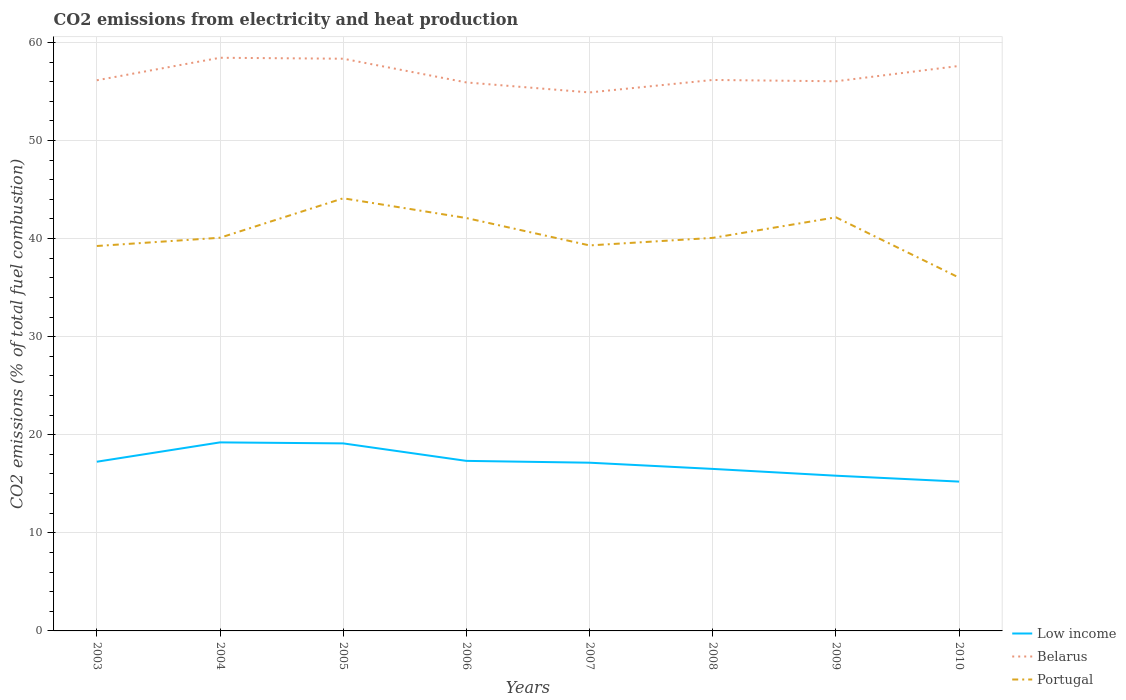Across all years, what is the maximum amount of CO2 emitted in Belarus?
Your answer should be compact. 54.9. In which year was the amount of CO2 emitted in Low income maximum?
Provide a succinct answer. 2010. What is the total amount of CO2 emitted in Low income in the graph?
Your response must be concise. 2.7. What is the difference between the highest and the second highest amount of CO2 emitted in Portugal?
Provide a succinct answer. 8.09. How many lines are there?
Your answer should be compact. 3. How many years are there in the graph?
Keep it short and to the point. 8. Does the graph contain any zero values?
Your answer should be very brief. No. Where does the legend appear in the graph?
Your response must be concise. Bottom right. What is the title of the graph?
Your answer should be very brief. CO2 emissions from electricity and heat production. Does "Pakistan" appear as one of the legend labels in the graph?
Provide a succinct answer. No. What is the label or title of the Y-axis?
Keep it short and to the point. CO2 emissions (% of total fuel combustion). What is the CO2 emissions (% of total fuel combustion) in Low income in 2003?
Give a very brief answer. 17.25. What is the CO2 emissions (% of total fuel combustion) in Belarus in 2003?
Keep it short and to the point. 56.14. What is the CO2 emissions (% of total fuel combustion) in Portugal in 2003?
Give a very brief answer. 39.24. What is the CO2 emissions (% of total fuel combustion) in Low income in 2004?
Keep it short and to the point. 19.22. What is the CO2 emissions (% of total fuel combustion) of Belarus in 2004?
Provide a succinct answer. 58.43. What is the CO2 emissions (% of total fuel combustion) of Portugal in 2004?
Your response must be concise. 40.08. What is the CO2 emissions (% of total fuel combustion) in Low income in 2005?
Offer a terse response. 19.12. What is the CO2 emissions (% of total fuel combustion) in Belarus in 2005?
Your response must be concise. 58.34. What is the CO2 emissions (% of total fuel combustion) in Portugal in 2005?
Your answer should be very brief. 44.11. What is the CO2 emissions (% of total fuel combustion) in Low income in 2006?
Provide a short and direct response. 17.34. What is the CO2 emissions (% of total fuel combustion) of Belarus in 2006?
Your answer should be very brief. 55.92. What is the CO2 emissions (% of total fuel combustion) in Portugal in 2006?
Offer a very short reply. 42.09. What is the CO2 emissions (% of total fuel combustion) in Low income in 2007?
Ensure brevity in your answer.  17.15. What is the CO2 emissions (% of total fuel combustion) of Belarus in 2007?
Ensure brevity in your answer.  54.9. What is the CO2 emissions (% of total fuel combustion) in Portugal in 2007?
Offer a terse response. 39.3. What is the CO2 emissions (% of total fuel combustion) in Low income in 2008?
Provide a short and direct response. 16.52. What is the CO2 emissions (% of total fuel combustion) of Belarus in 2008?
Offer a terse response. 56.17. What is the CO2 emissions (% of total fuel combustion) in Portugal in 2008?
Offer a terse response. 40.07. What is the CO2 emissions (% of total fuel combustion) of Low income in 2009?
Give a very brief answer. 15.82. What is the CO2 emissions (% of total fuel combustion) of Belarus in 2009?
Ensure brevity in your answer.  56.04. What is the CO2 emissions (% of total fuel combustion) in Portugal in 2009?
Ensure brevity in your answer.  42.17. What is the CO2 emissions (% of total fuel combustion) in Low income in 2010?
Offer a very short reply. 15.22. What is the CO2 emissions (% of total fuel combustion) of Belarus in 2010?
Make the answer very short. 57.6. What is the CO2 emissions (% of total fuel combustion) of Portugal in 2010?
Your answer should be compact. 36.02. Across all years, what is the maximum CO2 emissions (% of total fuel combustion) of Low income?
Give a very brief answer. 19.22. Across all years, what is the maximum CO2 emissions (% of total fuel combustion) in Belarus?
Your answer should be compact. 58.43. Across all years, what is the maximum CO2 emissions (% of total fuel combustion) in Portugal?
Make the answer very short. 44.11. Across all years, what is the minimum CO2 emissions (% of total fuel combustion) of Low income?
Keep it short and to the point. 15.22. Across all years, what is the minimum CO2 emissions (% of total fuel combustion) in Belarus?
Keep it short and to the point. 54.9. Across all years, what is the minimum CO2 emissions (% of total fuel combustion) of Portugal?
Provide a short and direct response. 36.02. What is the total CO2 emissions (% of total fuel combustion) in Low income in the graph?
Your response must be concise. 137.64. What is the total CO2 emissions (% of total fuel combustion) in Belarus in the graph?
Ensure brevity in your answer.  453.53. What is the total CO2 emissions (% of total fuel combustion) of Portugal in the graph?
Keep it short and to the point. 323.08. What is the difference between the CO2 emissions (% of total fuel combustion) in Low income in 2003 and that in 2004?
Make the answer very short. -1.97. What is the difference between the CO2 emissions (% of total fuel combustion) of Belarus in 2003 and that in 2004?
Provide a short and direct response. -2.29. What is the difference between the CO2 emissions (% of total fuel combustion) of Portugal in 2003 and that in 2004?
Your answer should be very brief. -0.84. What is the difference between the CO2 emissions (% of total fuel combustion) in Low income in 2003 and that in 2005?
Your answer should be very brief. -1.87. What is the difference between the CO2 emissions (% of total fuel combustion) in Belarus in 2003 and that in 2005?
Provide a succinct answer. -2.2. What is the difference between the CO2 emissions (% of total fuel combustion) of Portugal in 2003 and that in 2005?
Ensure brevity in your answer.  -4.86. What is the difference between the CO2 emissions (% of total fuel combustion) of Low income in 2003 and that in 2006?
Make the answer very short. -0.09. What is the difference between the CO2 emissions (% of total fuel combustion) in Belarus in 2003 and that in 2006?
Make the answer very short. 0.22. What is the difference between the CO2 emissions (% of total fuel combustion) of Portugal in 2003 and that in 2006?
Make the answer very short. -2.85. What is the difference between the CO2 emissions (% of total fuel combustion) in Low income in 2003 and that in 2007?
Keep it short and to the point. 0.1. What is the difference between the CO2 emissions (% of total fuel combustion) in Belarus in 2003 and that in 2007?
Provide a short and direct response. 1.24. What is the difference between the CO2 emissions (% of total fuel combustion) of Portugal in 2003 and that in 2007?
Your response must be concise. -0.06. What is the difference between the CO2 emissions (% of total fuel combustion) in Low income in 2003 and that in 2008?
Keep it short and to the point. 0.73. What is the difference between the CO2 emissions (% of total fuel combustion) in Belarus in 2003 and that in 2008?
Provide a short and direct response. -0.03. What is the difference between the CO2 emissions (% of total fuel combustion) in Portugal in 2003 and that in 2008?
Keep it short and to the point. -0.83. What is the difference between the CO2 emissions (% of total fuel combustion) of Low income in 2003 and that in 2009?
Your answer should be very brief. 1.43. What is the difference between the CO2 emissions (% of total fuel combustion) in Belarus in 2003 and that in 2009?
Your answer should be very brief. 0.1. What is the difference between the CO2 emissions (% of total fuel combustion) in Portugal in 2003 and that in 2009?
Your answer should be very brief. -2.92. What is the difference between the CO2 emissions (% of total fuel combustion) of Low income in 2003 and that in 2010?
Ensure brevity in your answer.  2.03. What is the difference between the CO2 emissions (% of total fuel combustion) in Belarus in 2003 and that in 2010?
Make the answer very short. -1.46. What is the difference between the CO2 emissions (% of total fuel combustion) in Portugal in 2003 and that in 2010?
Offer a very short reply. 3.23. What is the difference between the CO2 emissions (% of total fuel combustion) in Low income in 2004 and that in 2005?
Ensure brevity in your answer.  0.1. What is the difference between the CO2 emissions (% of total fuel combustion) of Belarus in 2004 and that in 2005?
Provide a succinct answer. 0.1. What is the difference between the CO2 emissions (% of total fuel combustion) in Portugal in 2004 and that in 2005?
Your response must be concise. -4.02. What is the difference between the CO2 emissions (% of total fuel combustion) of Low income in 2004 and that in 2006?
Your answer should be compact. 1.89. What is the difference between the CO2 emissions (% of total fuel combustion) of Belarus in 2004 and that in 2006?
Ensure brevity in your answer.  2.52. What is the difference between the CO2 emissions (% of total fuel combustion) of Portugal in 2004 and that in 2006?
Provide a succinct answer. -2.01. What is the difference between the CO2 emissions (% of total fuel combustion) in Low income in 2004 and that in 2007?
Ensure brevity in your answer.  2.07. What is the difference between the CO2 emissions (% of total fuel combustion) of Belarus in 2004 and that in 2007?
Ensure brevity in your answer.  3.54. What is the difference between the CO2 emissions (% of total fuel combustion) in Portugal in 2004 and that in 2007?
Make the answer very short. 0.78. What is the difference between the CO2 emissions (% of total fuel combustion) in Low income in 2004 and that in 2008?
Offer a very short reply. 2.7. What is the difference between the CO2 emissions (% of total fuel combustion) in Belarus in 2004 and that in 2008?
Your response must be concise. 2.26. What is the difference between the CO2 emissions (% of total fuel combustion) of Portugal in 2004 and that in 2008?
Provide a succinct answer. 0.01. What is the difference between the CO2 emissions (% of total fuel combustion) in Low income in 2004 and that in 2009?
Give a very brief answer. 3.4. What is the difference between the CO2 emissions (% of total fuel combustion) of Belarus in 2004 and that in 2009?
Your answer should be very brief. 2.4. What is the difference between the CO2 emissions (% of total fuel combustion) of Portugal in 2004 and that in 2009?
Offer a very short reply. -2.08. What is the difference between the CO2 emissions (% of total fuel combustion) of Low income in 2004 and that in 2010?
Offer a terse response. 4. What is the difference between the CO2 emissions (% of total fuel combustion) of Belarus in 2004 and that in 2010?
Give a very brief answer. 0.83. What is the difference between the CO2 emissions (% of total fuel combustion) of Portugal in 2004 and that in 2010?
Provide a short and direct response. 4.07. What is the difference between the CO2 emissions (% of total fuel combustion) of Low income in 2005 and that in 2006?
Make the answer very short. 1.78. What is the difference between the CO2 emissions (% of total fuel combustion) of Belarus in 2005 and that in 2006?
Your answer should be compact. 2.42. What is the difference between the CO2 emissions (% of total fuel combustion) of Portugal in 2005 and that in 2006?
Keep it short and to the point. 2.01. What is the difference between the CO2 emissions (% of total fuel combustion) of Low income in 2005 and that in 2007?
Your answer should be very brief. 1.97. What is the difference between the CO2 emissions (% of total fuel combustion) in Belarus in 2005 and that in 2007?
Provide a short and direct response. 3.44. What is the difference between the CO2 emissions (% of total fuel combustion) of Portugal in 2005 and that in 2007?
Your answer should be compact. 4.8. What is the difference between the CO2 emissions (% of total fuel combustion) in Low income in 2005 and that in 2008?
Ensure brevity in your answer.  2.6. What is the difference between the CO2 emissions (% of total fuel combustion) of Belarus in 2005 and that in 2008?
Make the answer very short. 2.17. What is the difference between the CO2 emissions (% of total fuel combustion) of Portugal in 2005 and that in 2008?
Provide a short and direct response. 4.04. What is the difference between the CO2 emissions (% of total fuel combustion) of Low income in 2005 and that in 2009?
Your answer should be compact. 3.29. What is the difference between the CO2 emissions (% of total fuel combustion) of Belarus in 2005 and that in 2009?
Offer a very short reply. 2.3. What is the difference between the CO2 emissions (% of total fuel combustion) in Portugal in 2005 and that in 2009?
Keep it short and to the point. 1.94. What is the difference between the CO2 emissions (% of total fuel combustion) in Low income in 2005 and that in 2010?
Your response must be concise. 3.89. What is the difference between the CO2 emissions (% of total fuel combustion) of Belarus in 2005 and that in 2010?
Keep it short and to the point. 0.74. What is the difference between the CO2 emissions (% of total fuel combustion) of Portugal in 2005 and that in 2010?
Your response must be concise. 8.09. What is the difference between the CO2 emissions (% of total fuel combustion) of Low income in 2006 and that in 2007?
Keep it short and to the point. 0.19. What is the difference between the CO2 emissions (% of total fuel combustion) in Belarus in 2006 and that in 2007?
Ensure brevity in your answer.  1.02. What is the difference between the CO2 emissions (% of total fuel combustion) in Portugal in 2006 and that in 2007?
Provide a succinct answer. 2.79. What is the difference between the CO2 emissions (% of total fuel combustion) in Low income in 2006 and that in 2008?
Keep it short and to the point. 0.82. What is the difference between the CO2 emissions (% of total fuel combustion) in Belarus in 2006 and that in 2008?
Make the answer very short. -0.25. What is the difference between the CO2 emissions (% of total fuel combustion) in Portugal in 2006 and that in 2008?
Your response must be concise. 2.02. What is the difference between the CO2 emissions (% of total fuel combustion) in Low income in 2006 and that in 2009?
Offer a very short reply. 1.51. What is the difference between the CO2 emissions (% of total fuel combustion) in Belarus in 2006 and that in 2009?
Your response must be concise. -0.12. What is the difference between the CO2 emissions (% of total fuel combustion) in Portugal in 2006 and that in 2009?
Offer a very short reply. -0.07. What is the difference between the CO2 emissions (% of total fuel combustion) of Low income in 2006 and that in 2010?
Provide a succinct answer. 2.11. What is the difference between the CO2 emissions (% of total fuel combustion) in Belarus in 2006 and that in 2010?
Provide a succinct answer. -1.68. What is the difference between the CO2 emissions (% of total fuel combustion) in Portugal in 2006 and that in 2010?
Your answer should be compact. 6.08. What is the difference between the CO2 emissions (% of total fuel combustion) of Low income in 2007 and that in 2008?
Provide a succinct answer. 0.63. What is the difference between the CO2 emissions (% of total fuel combustion) of Belarus in 2007 and that in 2008?
Your answer should be compact. -1.27. What is the difference between the CO2 emissions (% of total fuel combustion) in Portugal in 2007 and that in 2008?
Offer a very short reply. -0.77. What is the difference between the CO2 emissions (% of total fuel combustion) of Low income in 2007 and that in 2009?
Keep it short and to the point. 1.33. What is the difference between the CO2 emissions (% of total fuel combustion) of Belarus in 2007 and that in 2009?
Your response must be concise. -1.14. What is the difference between the CO2 emissions (% of total fuel combustion) in Portugal in 2007 and that in 2009?
Make the answer very short. -2.86. What is the difference between the CO2 emissions (% of total fuel combustion) of Low income in 2007 and that in 2010?
Provide a short and direct response. 1.93. What is the difference between the CO2 emissions (% of total fuel combustion) of Belarus in 2007 and that in 2010?
Offer a terse response. -2.7. What is the difference between the CO2 emissions (% of total fuel combustion) in Portugal in 2007 and that in 2010?
Your answer should be compact. 3.29. What is the difference between the CO2 emissions (% of total fuel combustion) of Low income in 2008 and that in 2009?
Your answer should be very brief. 0.69. What is the difference between the CO2 emissions (% of total fuel combustion) in Belarus in 2008 and that in 2009?
Offer a terse response. 0.13. What is the difference between the CO2 emissions (% of total fuel combustion) of Portugal in 2008 and that in 2009?
Ensure brevity in your answer.  -2.1. What is the difference between the CO2 emissions (% of total fuel combustion) in Low income in 2008 and that in 2010?
Give a very brief answer. 1.29. What is the difference between the CO2 emissions (% of total fuel combustion) of Belarus in 2008 and that in 2010?
Your answer should be very brief. -1.43. What is the difference between the CO2 emissions (% of total fuel combustion) in Portugal in 2008 and that in 2010?
Provide a short and direct response. 4.05. What is the difference between the CO2 emissions (% of total fuel combustion) of Low income in 2009 and that in 2010?
Offer a very short reply. 0.6. What is the difference between the CO2 emissions (% of total fuel combustion) in Belarus in 2009 and that in 2010?
Offer a very short reply. -1.56. What is the difference between the CO2 emissions (% of total fuel combustion) of Portugal in 2009 and that in 2010?
Give a very brief answer. 6.15. What is the difference between the CO2 emissions (% of total fuel combustion) in Low income in 2003 and the CO2 emissions (% of total fuel combustion) in Belarus in 2004?
Your response must be concise. -41.18. What is the difference between the CO2 emissions (% of total fuel combustion) in Low income in 2003 and the CO2 emissions (% of total fuel combustion) in Portugal in 2004?
Make the answer very short. -22.83. What is the difference between the CO2 emissions (% of total fuel combustion) in Belarus in 2003 and the CO2 emissions (% of total fuel combustion) in Portugal in 2004?
Offer a very short reply. 16.06. What is the difference between the CO2 emissions (% of total fuel combustion) in Low income in 2003 and the CO2 emissions (% of total fuel combustion) in Belarus in 2005?
Provide a succinct answer. -41.09. What is the difference between the CO2 emissions (% of total fuel combustion) of Low income in 2003 and the CO2 emissions (% of total fuel combustion) of Portugal in 2005?
Ensure brevity in your answer.  -26.86. What is the difference between the CO2 emissions (% of total fuel combustion) in Belarus in 2003 and the CO2 emissions (% of total fuel combustion) in Portugal in 2005?
Provide a succinct answer. 12.03. What is the difference between the CO2 emissions (% of total fuel combustion) in Low income in 2003 and the CO2 emissions (% of total fuel combustion) in Belarus in 2006?
Your answer should be compact. -38.67. What is the difference between the CO2 emissions (% of total fuel combustion) in Low income in 2003 and the CO2 emissions (% of total fuel combustion) in Portugal in 2006?
Offer a terse response. -24.84. What is the difference between the CO2 emissions (% of total fuel combustion) in Belarus in 2003 and the CO2 emissions (% of total fuel combustion) in Portugal in 2006?
Provide a short and direct response. 14.05. What is the difference between the CO2 emissions (% of total fuel combustion) of Low income in 2003 and the CO2 emissions (% of total fuel combustion) of Belarus in 2007?
Make the answer very short. -37.65. What is the difference between the CO2 emissions (% of total fuel combustion) in Low income in 2003 and the CO2 emissions (% of total fuel combustion) in Portugal in 2007?
Your response must be concise. -22.05. What is the difference between the CO2 emissions (% of total fuel combustion) of Belarus in 2003 and the CO2 emissions (% of total fuel combustion) of Portugal in 2007?
Your response must be concise. 16.84. What is the difference between the CO2 emissions (% of total fuel combustion) in Low income in 2003 and the CO2 emissions (% of total fuel combustion) in Belarus in 2008?
Your answer should be very brief. -38.92. What is the difference between the CO2 emissions (% of total fuel combustion) in Low income in 2003 and the CO2 emissions (% of total fuel combustion) in Portugal in 2008?
Your answer should be very brief. -22.82. What is the difference between the CO2 emissions (% of total fuel combustion) of Belarus in 2003 and the CO2 emissions (% of total fuel combustion) of Portugal in 2008?
Keep it short and to the point. 16.07. What is the difference between the CO2 emissions (% of total fuel combustion) of Low income in 2003 and the CO2 emissions (% of total fuel combustion) of Belarus in 2009?
Your answer should be very brief. -38.79. What is the difference between the CO2 emissions (% of total fuel combustion) of Low income in 2003 and the CO2 emissions (% of total fuel combustion) of Portugal in 2009?
Your answer should be compact. -24.92. What is the difference between the CO2 emissions (% of total fuel combustion) in Belarus in 2003 and the CO2 emissions (% of total fuel combustion) in Portugal in 2009?
Your response must be concise. 13.97. What is the difference between the CO2 emissions (% of total fuel combustion) of Low income in 2003 and the CO2 emissions (% of total fuel combustion) of Belarus in 2010?
Offer a very short reply. -40.35. What is the difference between the CO2 emissions (% of total fuel combustion) of Low income in 2003 and the CO2 emissions (% of total fuel combustion) of Portugal in 2010?
Provide a succinct answer. -18.77. What is the difference between the CO2 emissions (% of total fuel combustion) in Belarus in 2003 and the CO2 emissions (% of total fuel combustion) in Portugal in 2010?
Give a very brief answer. 20.12. What is the difference between the CO2 emissions (% of total fuel combustion) of Low income in 2004 and the CO2 emissions (% of total fuel combustion) of Belarus in 2005?
Provide a succinct answer. -39.11. What is the difference between the CO2 emissions (% of total fuel combustion) in Low income in 2004 and the CO2 emissions (% of total fuel combustion) in Portugal in 2005?
Your answer should be very brief. -24.89. What is the difference between the CO2 emissions (% of total fuel combustion) of Belarus in 2004 and the CO2 emissions (% of total fuel combustion) of Portugal in 2005?
Give a very brief answer. 14.33. What is the difference between the CO2 emissions (% of total fuel combustion) in Low income in 2004 and the CO2 emissions (% of total fuel combustion) in Belarus in 2006?
Your answer should be compact. -36.7. What is the difference between the CO2 emissions (% of total fuel combustion) of Low income in 2004 and the CO2 emissions (% of total fuel combustion) of Portugal in 2006?
Provide a short and direct response. -22.87. What is the difference between the CO2 emissions (% of total fuel combustion) of Belarus in 2004 and the CO2 emissions (% of total fuel combustion) of Portugal in 2006?
Your answer should be very brief. 16.34. What is the difference between the CO2 emissions (% of total fuel combustion) of Low income in 2004 and the CO2 emissions (% of total fuel combustion) of Belarus in 2007?
Your response must be concise. -35.68. What is the difference between the CO2 emissions (% of total fuel combustion) in Low income in 2004 and the CO2 emissions (% of total fuel combustion) in Portugal in 2007?
Give a very brief answer. -20.08. What is the difference between the CO2 emissions (% of total fuel combustion) in Belarus in 2004 and the CO2 emissions (% of total fuel combustion) in Portugal in 2007?
Your answer should be compact. 19.13. What is the difference between the CO2 emissions (% of total fuel combustion) in Low income in 2004 and the CO2 emissions (% of total fuel combustion) in Belarus in 2008?
Offer a very short reply. -36.95. What is the difference between the CO2 emissions (% of total fuel combustion) in Low income in 2004 and the CO2 emissions (% of total fuel combustion) in Portugal in 2008?
Your response must be concise. -20.85. What is the difference between the CO2 emissions (% of total fuel combustion) of Belarus in 2004 and the CO2 emissions (% of total fuel combustion) of Portugal in 2008?
Your answer should be very brief. 18.36. What is the difference between the CO2 emissions (% of total fuel combustion) in Low income in 2004 and the CO2 emissions (% of total fuel combustion) in Belarus in 2009?
Ensure brevity in your answer.  -36.82. What is the difference between the CO2 emissions (% of total fuel combustion) of Low income in 2004 and the CO2 emissions (% of total fuel combustion) of Portugal in 2009?
Keep it short and to the point. -22.95. What is the difference between the CO2 emissions (% of total fuel combustion) in Belarus in 2004 and the CO2 emissions (% of total fuel combustion) in Portugal in 2009?
Ensure brevity in your answer.  16.27. What is the difference between the CO2 emissions (% of total fuel combustion) of Low income in 2004 and the CO2 emissions (% of total fuel combustion) of Belarus in 2010?
Offer a terse response. -38.38. What is the difference between the CO2 emissions (% of total fuel combustion) of Low income in 2004 and the CO2 emissions (% of total fuel combustion) of Portugal in 2010?
Your answer should be very brief. -16.79. What is the difference between the CO2 emissions (% of total fuel combustion) in Belarus in 2004 and the CO2 emissions (% of total fuel combustion) in Portugal in 2010?
Your response must be concise. 22.42. What is the difference between the CO2 emissions (% of total fuel combustion) in Low income in 2005 and the CO2 emissions (% of total fuel combustion) in Belarus in 2006?
Make the answer very short. -36.8. What is the difference between the CO2 emissions (% of total fuel combustion) in Low income in 2005 and the CO2 emissions (% of total fuel combustion) in Portugal in 2006?
Provide a succinct answer. -22.98. What is the difference between the CO2 emissions (% of total fuel combustion) in Belarus in 2005 and the CO2 emissions (% of total fuel combustion) in Portugal in 2006?
Make the answer very short. 16.24. What is the difference between the CO2 emissions (% of total fuel combustion) in Low income in 2005 and the CO2 emissions (% of total fuel combustion) in Belarus in 2007?
Ensure brevity in your answer.  -35.78. What is the difference between the CO2 emissions (% of total fuel combustion) in Low income in 2005 and the CO2 emissions (% of total fuel combustion) in Portugal in 2007?
Offer a very short reply. -20.18. What is the difference between the CO2 emissions (% of total fuel combustion) in Belarus in 2005 and the CO2 emissions (% of total fuel combustion) in Portugal in 2007?
Keep it short and to the point. 19.03. What is the difference between the CO2 emissions (% of total fuel combustion) in Low income in 2005 and the CO2 emissions (% of total fuel combustion) in Belarus in 2008?
Keep it short and to the point. -37.05. What is the difference between the CO2 emissions (% of total fuel combustion) in Low income in 2005 and the CO2 emissions (% of total fuel combustion) in Portugal in 2008?
Keep it short and to the point. -20.95. What is the difference between the CO2 emissions (% of total fuel combustion) of Belarus in 2005 and the CO2 emissions (% of total fuel combustion) of Portugal in 2008?
Make the answer very short. 18.27. What is the difference between the CO2 emissions (% of total fuel combustion) in Low income in 2005 and the CO2 emissions (% of total fuel combustion) in Belarus in 2009?
Ensure brevity in your answer.  -36.92. What is the difference between the CO2 emissions (% of total fuel combustion) in Low income in 2005 and the CO2 emissions (% of total fuel combustion) in Portugal in 2009?
Keep it short and to the point. -23.05. What is the difference between the CO2 emissions (% of total fuel combustion) of Belarus in 2005 and the CO2 emissions (% of total fuel combustion) of Portugal in 2009?
Your answer should be compact. 16.17. What is the difference between the CO2 emissions (% of total fuel combustion) in Low income in 2005 and the CO2 emissions (% of total fuel combustion) in Belarus in 2010?
Provide a short and direct response. -38.48. What is the difference between the CO2 emissions (% of total fuel combustion) of Low income in 2005 and the CO2 emissions (% of total fuel combustion) of Portugal in 2010?
Your response must be concise. -16.9. What is the difference between the CO2 emissions (% of total fuel combustion) in Belarus in 2005 and the CO2 emissions (% of total fuel combustion) in Portugal in 2010?
Your response must be concise. 22.32. What is the difference between the CO2 emissions (% of total fuel combustion) in Low income in 2006 and the CO2 emissions (% of total fuel combustion) in Belarus in 2007?
Your answer should be very brief. -37.56. What is the difference between the CO2 emissions (% of total fuel combustion) of Low income in 2006 and the CO2 emissions (% of total fuel combustion) of Portugal in 2007?
Your answer should be compact. -21.97. What is the difference between the CO2 emissions (% of total fuel combustion) of Belarus in 2006 and the CO2 emissions (% of total fuel combustion) of Portugal in 2007?
Offer a terse response. 16.62. What is the difference between the CO2 emissions (% of total fuel combustion) of Low income in 2006 and the CO2 emissions (% of total fuel combustion) of Belarus in 2008?
Keep it short and to the point. -38.83. What is the difference between the CO2 emissions (% of total fuel combustion) in Low income in 2006 and the CO2 emissions (% of total fuel combustion) in Portugal in 2008?
Your response must be concise. -22.73. What is the difference between the CO2 emissions (% of total fuel combustion) in Belarus in 2006 and the CO2 emissions (% of total fuel combustion) in Portugal in 2008?
Make the answer very short. 15.85. What is the difference between the CO2 emissions (% of total fuel combustion) in Low income in 2006 and the CO2 emissions (% of total fuel combustion) in Belarus in 2009?
Provide a short and direct response. -38.7. What is the difference between the CO2 emissions (% of total fuel combustion) of Low income in 2006 and the CO2 emissions (% of total fuel combustion) of Portugal in 2009?
Keep it short and to the point. -24.83. What is the difference between the CO2 emissions (% of total fuel combustion) in Belarus in 2006 and the CO2 emissions (% of total fuel combustion) in Portugal in 2009?
Offer a terse response. 13.75. What is the difference between the CO2 emissions (% of total fuel combustion) of Low income in 2006 and the CO2 emissions (% of total fuel combustion) of Belarus in 2010?
Offer a terse response. -40.26. What is the difference between the CO2 emissions (% of total fuel combustion) of Low income in 2006 and the CO2 emissions (% of total fuel combustion) of Portugal in 2010?
Your answer should be very brief. -18.68. What is the difference between the CO2 emissions (% of total fuel combustion) in Belarus in 2006 and the CO2 emissions (% of total fuel combustion) in Portugal in 2010?
Your answer should be very brief. 19.9. What is the difference between the CO2 emissions (% of total fuel combustion) of Low income in 2007 and the CO2 emissions (% of total fuel combustion) of Belarus in 2008?
Offer a very short reply. -39.02. What is the difference between the CO2 emissions (% of total fuel combustion) of Low income in 2007 and the CO2 emissions (% of total fuel combustion) of Portugal in 2008?
Ensure brevity in your answer.  -22.92. What is the difference between the CO2 emissions (% of total fuel combustion) in Belarus in 2007 and the CO2 emissions (% of total fuel combustion) in Portugal in 2008?
Keep it short and to the point. 14.83. What is the difference between the CO2 emissions (% of total fuel combustion) of Low income in 2007 and the CO2 emissions (% of total fuel combustion) of Belarus in 2009?
Make the answer very short. -38.89. What is the difference between the CO2 emissions (% of total fuel combustion) in Low income in 2007 and the CO2 emissions (% of total fuel combustion) in Portugal in 2009?
Provide a short and direct response. -25.02. What is the difference between the CO2 emissions (% of total fuel combustion) of Belarus in 2007 and the CO2 emissions (% of total fuel combustion) of Portugal in 2009?
Your answer should be very brief. 12.73. What is the difference between the CO2 emissions (% of total fuel combustion) in Low income in 2007 and the CO2 emissions (% of total fuel combustion) in Belarus in 2010?
Ensure brevity in your answer.  -40.45. What is the difference between the CO2 emissions (% of total fuel combustion) in Low income in 2007 and the CO2 emissions (% of total fuel combustion) in Portugal in 2010?
Keep it short and to the point. -18.87. What is the difference between the CO2 emissions (% of total fuel combustion) in Belarus in 2007 and the CO2 emissions (% of total fuel combustion) in Portugal in 2010?
Offer a terse response. 18.88. What is the difference between the CO2 emissions (% of total fuel combustion) in Low income in 2008 and the CO2 emissions (% of total fuel combustion) in Belarus in 2009?
Your answer should be very brief. -39.52. What is the difference between the CO2 emissions (% of total fuel combustion) of Low income in 2008 and the CO2 emissions (% of total fuel combustion) of Portugal in 2009?
Offer a very short reply. -25.65. What is the difference between the CO2 emissions (% of total fuel combustion) of Belarus in 2008 and the CO2 emissions (% of total fuel combustion) of Portugal in 2009?
Offer a very short reply. 14. What is the difference between the CO2 emissions (% of total fuel combustion) in Low income in 2008 and the CO2 emissions (% of total fuel combustion) in Belarus in 2010?
Give a very brief answer. -41.08. What is the difference between the CO2 emissions (% of total fuel combustion) in Low income in 2008 and the CO2 emissions (% of total fuel combustion) in Portugal in 2010?
Offer a very short reply. -19.5. What is the difference between the CO2 emissions (% of total fuel combustion) in Belarus in 2008 and the CO2 emissions (% of total fuel combustion) in Portugal in 2010?
Keep it short and to the point. 20.15. What is the difference between the CO2 emissions (% of total fuel combustion) of Low income in 2009 and the CO2 emissions (% of total fuel combustion) of Belarus in 2010?
Give a very brief answer. -41.78. What is the difference between the CO2 emissions (% of total fuel combustion) in Low income in 2009 and the CO2 emissions (% of total fuel combustion) in Portugal in 2010?
Provide a short and direct response. -20.19. What is the difference between the CO2 emissions (% of total fuel combustion) in Belarus in 2009 and the CO2 emissions (% of total fuel combustion) in Portugal in 2010?
Give a very brief answer. 20.02. What is the average CO2 emissions (% of total fuel combustion) of Low income per year?
Give a very brief answer. 17.21. What is the average CO2 emissions (% of total fuel combustion) in Belarus per year?
Ensure brevity in your answer.  56.69. What is the average CO2 emissions (% of total fuel combustion) of Portugal per year?
Offer a terse response. 40.39. In the year 2003, what is the difference between the CO2 emissions (% of total fuel combustion) of Low income and CO2 emissions (% of total fuel combustion) of Belarus?
Ensure brevity in your answer.  -38.89. In the year 2003, what is the difference between the CO2 emissions (% of total fuel combustion) in Low income and CO2 emissions (% of total fuel combustion) in Portugal?
Offer a terse response. -21.99. In the year 2003, what is the difference between the CO2 emissions (% of total fuel combustion) of Belarus and CO2 emissions (% of total fuel combustion) of Portugal?
Offer a terse response. 16.9. In the year 2004, what is the difference between the CO2 emissions (% of total fuel combustion) of Low income and CO2 emissions (% of total fuel combustion) of Belarus?
Your response must be concise. -39.21. In the year 2004, what is the difference between the CO2 emissions (% of total fuel combustion) of Low income and CO2 emissions (% of total fuel combustion) of Portugal?
Your answer should be compact. -20.86. In the year 2004, what is the difference between the CO2 emissions (% of total fuel combustion) in Belarus and CO2 emissions (% of total fuel combustion) in Portugal?
Your answer should be compact. 18.35. In the year 2005, what is the difference between the CO2 emissions (% of total fuel combustion) in Low income and CO2 emissions (% of total fuel combustion) in Belarus?
Your answer should be compact. -39.22. In the year 2005, what is the difference between the CO2 emissions (% of total fuel combustion) in Low income and CO2 emissions (% of total fuel combustion) in Portugal?
Keep it short and to the point. -24.99. In the year 2005, what is the difference between the CO2 emissions (% of total fuel combustion) of Belarus and CO2 emissions (% of total fuel combustion) of Portugal?
Offer a very short reply. 14.23. In the year 2006, what is the difference between the CO2 emissions (% of total fuel combustion) in Low income and CO2 emissions (% of total fuel combustion) in Belarus?
Keep it short and to the point. -38.58. In the year 2006, what is the difference between the CO2 emissions (% of total fuel combustion) of Low income and CO2 emissions (% of total fuel combustion) of Portugal?
Offer a terse response. -24.76. In the year 2006, what is the difference between the CO2 emissions (% of total fuel combustion) in Belarus and CO2 emissions (% of total fuel combustion) in Portugal?
Ensure brevity in your answer.  13.82. In the year 2007, what is the difference between the CO2 emissions (% of total fuel combustion) of Low income and CO2 emissions (% of total fuel combustion) of Belarus?
Ensure brevity in your answer.  -37.75. In the year 2007, what is the difference between the CO2 emissions (% of total fuel combustion) in Low income and CO2 emissions (% of total fuel combustion) in Portugal?
Provide a short and direct response. -22.15. In the year 2007, what is the difference between the CO2 emissions (% of total fuel combustion) of Belarus and CO2 emissions (% of total fuel combustion) of Portugal?
Provide a short and direct response. 15.6. In the year 2008, what is the difference between the CO2 emissions (% of total fuel combustion) of Low income and CO2 emissions (% of total fuel combustion) of Belarus?
Your answer should be compact. -39.65. In the year 2008, what is the difference between the CO2 emissions (% of total fuel combustion) of Low income and CO2 emissions (% of total fuel combustion) of Portugal?
Your answer should be very brief. -23.55. In the year 2008, what is the difference between the CO2 emissions (% of total fuel combustion) in Belarus and CO2 emissions (% of total fuel combustion) in Portugal?
Your response must be concise. 16.1. In the year 2009, what is the difference between the CO2 emissions (% of total fuel combustion) of Low income and CO2 emissions (% of total fuel combustion) of Belarus?
Provide a succinct answer. -40.21. In the year 2009, what is the difference between the CO2 emissions (% of total fuel combustion) in Low income and CO2 emissions (% of total fuel combustion) in Portugal?
Ensure brevity in your answer.  -26.34. In the year 2009, what is the difference between the CO2 emissions (% of total fuel combustion) in Belarus and CO2 emissions (% of total fuel combustion) in Portugal?
Your answer should be very brief. 13.87. In the year 2010, what is the difference between the CO2 emissions (% of total fuel combustion) of Low income and CO2 emissions (% of total fuel combustion) of Belarus?
Ensure brevity in your answer.  -42.38. In the year 2010, what is the difference between the CO2 emissions (% of total fuel combustion) in Low income and CO2 emissions (% of total fuel combustion) in Portugal?
Make the answer very short. -20.79. In the year 2010, what is the difference between the CO2 emissions (% of total fuel combustion) in Belarus and CO2 emissions (% of total fuel combustion) in Portugal?
Provide a succinct answer. 21.58. What is the ratio of the CO2 emissions (% of total fuel combustion) of Low income in 2003 to that in 2004?
Provide a short and direct response. 0.9. What is the ratio of the CO2 emissions (% of total fuel combustion) of Belarus in 2003 to that in 2004?
Offer a terse response. 0.96. What is the ratio of the CO2 emissions (% of total fuel combustion) of Low income in 2003 to that in 2005?
Provide a short and direct response. 0.9. What is the ratio of the CO2 emissions (% of total fuel combustion) of Belarus in 2003 to that in 2005?
Provide a succinct answer. 0.96. What is the ratio of the CO2 emissions (% of total fuel combustion) in Portugal in 2003 to that in 2005?
Ensure brevity in your answer.  0.89. What is the ratio of the CO2 emissions (% of total fuel combustion) of Portugal in 2003 to that in 2006?
Offer a terse response. 0.93. What is the ratio of the CO2 emissions (% of total fuel combustion) of Low income in 2003 to that in 2007?
Your response must be concise. 1.01. What is the ratio of the CO2 emissions (% of total fuel combustion) in Belarus in 2003 to that in 2007?
Keep it short and to the point. 1.02. What is the ratio of the CO2 emissions (% of total fuel combustion) of Low income in 2003 to that in 2008?
Your response must be concise. 1.04. What is the ratio of the CO2 emissions (% of total fuel combustion) in Belarus in 2003 to that in 2008?
Keep it short and to the point. 1. What is the ratio of the CO2 emissions (% of total fuel combustion) of Portugal in 2003 to that in 2008?
Your answer should be compact. 0.98. What is the ratio of the CO2 emissions (% of total fuel combustion) of Low income in 2003 to that in 2009?
Provide a succinct answer. 1.09. What is the ratio of the CO2 emissions (% of total fuel combustion) in Belarus in 2003 to that in 2009?
Ensure brevity in your answer.  1. What is the ratio of the CO2 emissions (% of total fuel combustion) in Portugal in 2003 to that in 2009?
Offer a terse response. 0.93. What is the ratio of the CO2 emissions (% of total fuel combustion) in Low income in 2003 to that in 2010?
Provide a short and direct response. 1.13. What is the ratio of the CO2 emissions (% of total fuel combustion) of Belarus in 2003 to that in 2010?
Make the answer very short. 0.97. What is the ratio of the CO2 emissions (% of total fuel combustion) of Portugal in 2003 to that in 2010?
Offer a very short reply. 1.09. What is the ratio of the CO2 emissions (% of total fuel combustion) in Low income in 2004 to that in 2005?
Keep it short and to the point. 1.01. What is the ratio of the CO2 emissions (% of total fuel combustion) in Belarus in 2004 to that in 2005?
Provide a succinct answer. 1. What is the ratio of the CO2 emissions (% of total fuel combustion) in Portugal in 2004 to that in 2005?
Offer a terse response. 0.91. What is the ratio of the CO2 emissions (% of total fuel combustion) of Low income in 2004 to that in 2006?
Offer a very short reply. 1.11. What is the ratio of the CO2 emissions (% of total fuel combustion) of Belarus in 2004 to that in 2006?
Your response must be concise. 1.04. What is the ratio of the CO2 emissions (% of total fuel combustion) of Portugal in 2004 to that in 2006?
Offer a terse response. 0.95. What is the ratio of the CO2 emissions (% of total fuel combustion) of Low income in 2004 to that in 2007?
Make the answer very short. 1.12. What is the ratio of the CO2 emissions (% of total fuel combustion) in Belarus in 2004 to that in 2007?
Make the answer very short. 1.06. What is the ratio of the CO2 emissions (% of total fuel combustion) in Portugal in 2004 to that in 2007?
Make the answer very short. 1.02. What is the ratio of the CO2 emissions (% of total fuel combustion) of Low income in 2004 to that in 2008?
Your answer should be very brief. 1.16. What is the ratio of the CO2 emissions (% of total fuel combustion) of Belarus in 2004 to that in 2008?
Make the answer very short. 1.04. What is the ratio of the CO2 emissions (% of total fuel combustion) of Low income in 2004 to that in 2009?
Make the answer very short. 1.21. What is the ratio of the CO2 emissions (% of total fuel combustion) of Belarus in 2004 to that in 2009?
Your answer should be very brief. 1.04. What is the ratio of the CO2 emissions (% of total fuel combustion) in Portugal in 2004 to that in 2009?
Offer a terse response. 0.95. What is the ratio of the CO2 emissions (% of total fuel combustion) in Low income in 2004 to that in 2010?
Keep it short and to the point. 1.26. What is the ratio of the CO2 emissions (% of total fuel combustion) in Belarus in 2004 to that in 2010?
Your answer should be compact. 1.01. What is the ratio of the CO2 emissions (% of total fuel combustion) in Portugal in 2004 to that in 2010?
Keep it short and to the point. 1.11. What is the ratio of the CO2 emissions (% of total fuel combustion) of Low income in 2005 to that in 2006?
Your answer should be compact. 1.1. What is the ratio of the CO2 emissions (% of total fuel combustion) in Belarus in 2005 to that in 2006?
Make the answer very short. 1.04. What is the ratio of the CO2 emissions (% of total fuel combustion) in Portugal in 2005 to that in 2006?
Offer a very short reply. 1.05. What is the ratio of the CO2 emissions (% of total fuel combustion) in Low income in 2005 to that in 2007?
Give a very brief answer. 1.11. What is the ratio of the CO2 emissions (% of total fuel combustion) in Belarus in 2005 to that in 2007?
Provide a short and direct response. 1.06. What is the ratio of the CO2 emissions (% of total fuel combustion) in Portugal in 2005 to that in 2007?
Offer a very short reply. 1.12. What is the ratio of the CO2 emissions (% of total fuel combustion) of Low income in 2005 to that in 2008?
Provide a succinct answer. 1.16. What is the ratio of the CO2 emissions (% of total fuel combustion) of Belarus in 2005 to that in 2008?
Your answer should be compact. 1.04. What is the ratio of the CO2 emissions (% of total fuel combustion) in Portugal in 2005 to that in 2008?
Your response must be concise. 1.1. What is the ratio of the CO2 emissions (% of total fuel combustion) in Low income in 2005 to that in 2009?
Provide a short and direct response. 1.21. What is the ratio of the CO2 emissions (% of total fuel combustion) in Belarus in 2005 to that in 2009?
Offer a very short reply. 1.04. What is the ratio of the CO2 emissions (% of total fuel combustion) of Portugal in 2005 to that in 2009?
Ensure brevity in your answer.  1.05. What is the ratio of the CO2 emissions (% of total fuel combustion) of Low income in 2005 to that in 2010?
Your answer should be very brief. 1.26. What is the ratio of the CO2 emissions (% of total fuel combustion) in Belarus in 2005 to that in 2010?
Keep it short and to the point. 1.01. What is the ratio of the CO2 emissions (% of total fuel combustion) of Portugal in 2005 to that in 2010?
Offer a very short reply. 1.22. What is the ratio of the CO2 emissions (% of total fuel combustion) of Low income in 2006 to that in 2007?
Your answer should be compact. 1.01. What is the ratio of the CO2 emissions (% of total fuel combustion) in Belarus in 2006 to that in 2007?
Keep it short and to the point. 1.02. What is the ratio of the CO2 emissions (% of total fuel combustion) in Portugal in 2006 to that in 2007?
Provide a succinct answer. 1.07. What is the ratio of the CO2 emissions (% of total fuel combustion) of Low income in 2006 to that in 2008?
Keep it short and to the point. 1.05. What is the ratio of the CO2 emissions (% of total fuel combustion) in Portugal in 2006 to that in 2008?
Provide a succinct answer. 1.05. What is the ratio of the CO2 emissions (% of total fuel combustion) of Low income in 2006 to that in 2009?
Provide a short and direct response. 1.1. What is the ratio of the CO2 emissions (% of total fuel combustion) in Portugal in 2006 to that in 2009?
Offer a very short reply. 1. What is the ratio of the CO2 emissions (% of total fuel combustion) in Low income in 2006 to that in 2010?
Ensure brevity in your answer.  1.14. What is the ratio of the CO2 emissions (% of total fuel combustion) of Belarus in 2006 to that in 2010?
Your answer should be very brief. 0.97. What is the ratio of the CO2 emissions (% of total fuel combustion) of Portugal in 2006 to that in 2010?
Your answer should be compact. 1.17. What is the ratio of the CO2 emissions (% of total fuel combustion) of Low income in 2007 to that in 2008?
Offer a terse response. 1.04. What is the ratio of the CO2 emissions (% of total fuel combustion) in Belarus in 2007 to that in 2008?
Ensure brevity in your answer.  0.98. What is the ratio of the CO2 emissions (% of total fuel combustion) of Portugal in 2007 to that in 2008?
Your answer should be very brief. 0.98. What is the ratio of the CO2 emissions (% of total fuel combustion) in Low income in 2007 to that in 2009?
Provide a short and direct response. 1.08. What is the ratio of the CO2 emissions (% of total fuel combustion) of Belarus in 2007 to that in 2009?
Make the answer very short. 0.98. What is the ratio of the CO2 emissions (% of total fuel combustion) of Portugal in 2007 to that in 2009?
Your answer should be compact. 0.93. What is the ratio of the CO2 emissions (% of total fuel combustion) of Low income in 2007 to that in 2010?
Ensure brevity in your answer.  1.13. What is the ratio of the CO2 emissions (% of total fuel combustion) of Belarus in 2007 to that in 2010?
Offer a very short reply. 0.95. What is the ratio of the CO2 emissions (% of total fuel combustion) in Portugal in 2007 to that in 2010?
Offer a very short reply. 1.09. What is the ratio of the CO2 emissions (% of total fuel combustion) in Low income in 2008 to that in 2009?
Offer a very short reply. 1.04. What is the ratio of the CO2 emissions (% of total fuel combustion) of Belarus in 2008 to that in 2009?
Offer a very short reply. 1. What is the ratio of the CO2 emissions (% of total fuel combustion) of Portugal in 2008 to that in 2009?
Your answer should be compact. 0.95. What is the ratio of the CO2 emissions (% of total fuel combustion) in Low income in 2008 to that in 2010?
Offer a very short reply. 1.08. What is the ratio of the CO2 emissions (% of total fuel combustion) in Belarus in 2008 to that in 2010?
Your response must be concise. 0.98. What is the ratio of the CO2 emissions (% of total fuel combustion) in Portugal in 2008 to that in 2010?
Your response must be concise. 1.11. What is the ratio of the CO2 emissions (% of total fuel combustion) in Low income in 2009 to that in 2010?
Your answer should be compact. 1.04. What is the ratio of the CO2 emissions (% of total fuel combustion) in Belarus in 2009 to that in 2010?
Your answer should be very brief. 0.97. What is the ratio of the CO2 emissions (% of total fuel combustion) in Portugal in 2009 to that in 2010?
Offer a terse response. 1.17. What is the difference between the highest and the second highest CO2 emissions (% of total fuel combustion) of Low income?
Offer a terse response. 0.1. What is the difference between the highest and the second highest CO2 emissions (% of total fuel combustion) in Belarus?
Your answer should be compact. 0.1. What is the difference between the highest and the second highest CO2 emissions (% of total fuel combustion) of Portugal?
Give a very brief answer. 1.94. What is the difference between the highest and the lowest CO2 emissions (% of total fuel combustion) in Low income?
Offer a very short reply. 4. What is the difference between the highest and the lowest CO2 emissions (% of total fuel combustion) of Belarus?
Offer a very short reply. 3.54. What is the difference between the highest and the lowest CO2 emissions (% of total fuel combustion) in Portugal?
Provide a short and direct response. 8.09. 